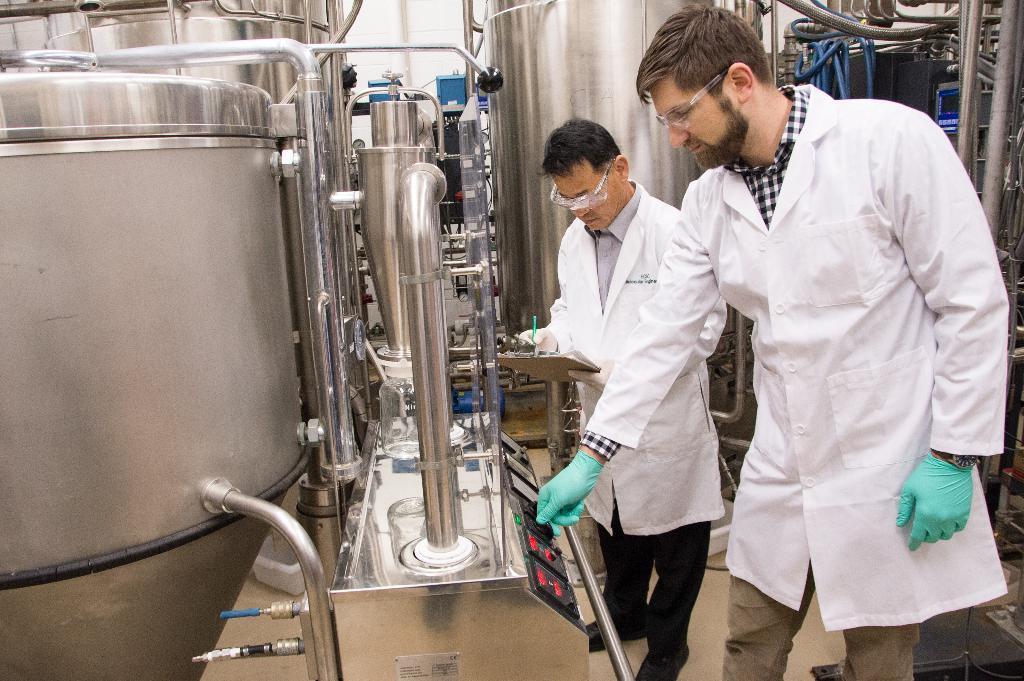Can you describe this image briefly? In this image, we can see steel tanks and some pipes. There is a regulator at the bottom of the image. There are two persons standing and wearing clothes. 